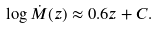Convert formula to latex. <formula><loc_0><loc_0><loc_500><loc_500>\log \dot { M } ( z ) \approx 0 . 6 z + C .</formula> 